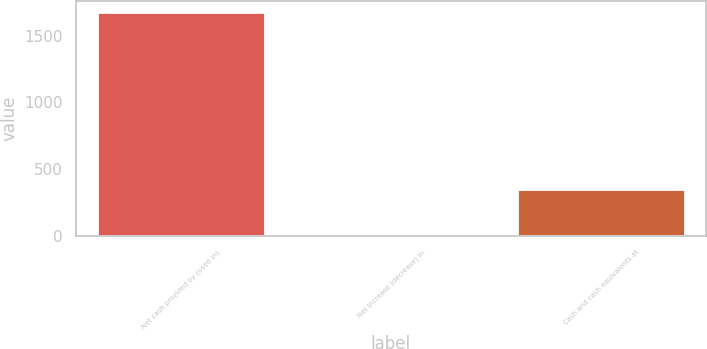<chart> <loc_0><loc_0><loc_500><loc_500><bar_chart><fcel>Net cash provided by (used in)<fcel>Net increase (decrease) in<fcel>Cash and cash equivalents at<nl><fcel>1675<fcel>15.6<fcel>347.48<nl></chart> 